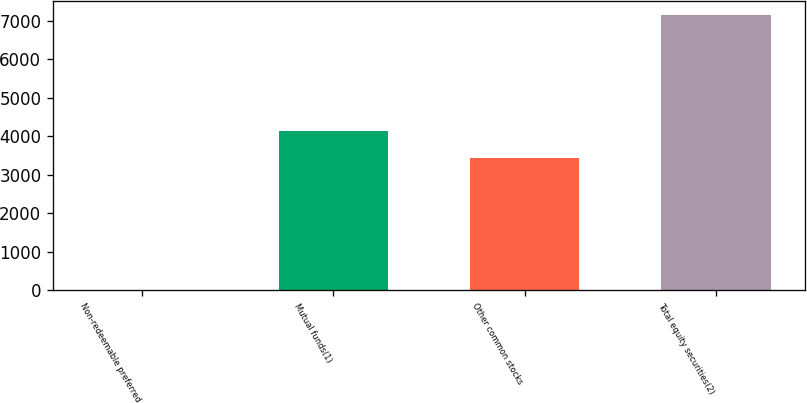<chart> <loc_0><loc_0><loc_500><loc_500><bar_chart><fcel>Non-redeemable preferred<fcel>Mutual funds(1)<fcel>Other common stocks<fcel>Total equity securities(2)<nl><fcel>7<fcel>4135.6<fcel>3420<fcel>7163<nl></chart> 